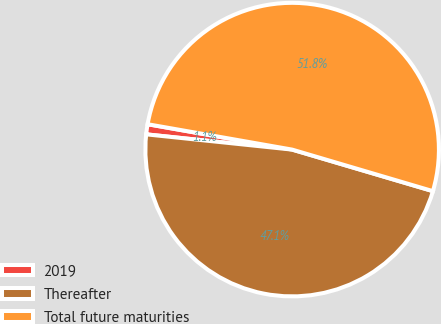<chart> <loc_0><loc_0><loc_500><loc_500><pie_chart><fcel>2019<fcel>Thereafter<fcel>Total future maturities<nl><fcel>1.11%<fcel>47.09%<fcel>51.8%<nl></chart> 